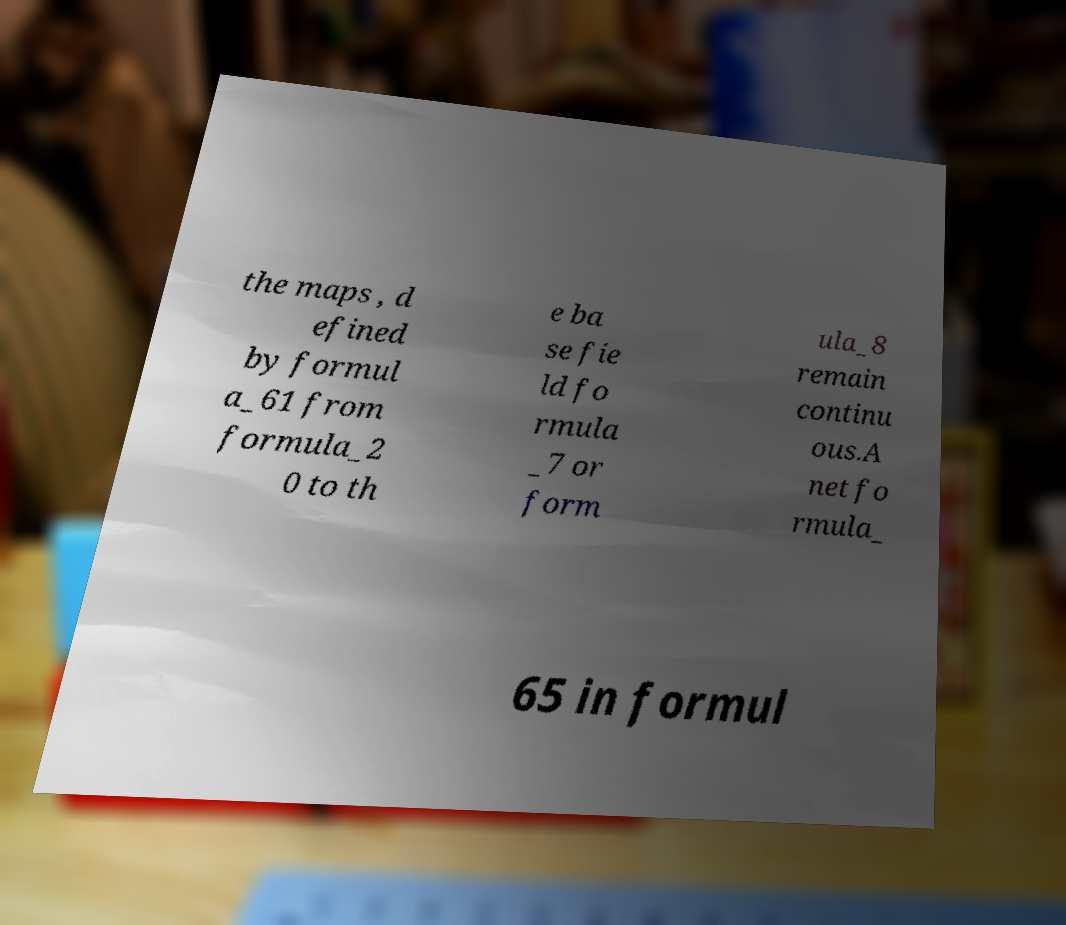For documentation purposes, I need the text within this image transcribed. Could you provide that? the maps , d efined by formul a_61 from formula_2 0 to th e ba se fie ld fo rmula _7 or form ula_8 remain continu ous.A net fo rmula_ 65 in formul 